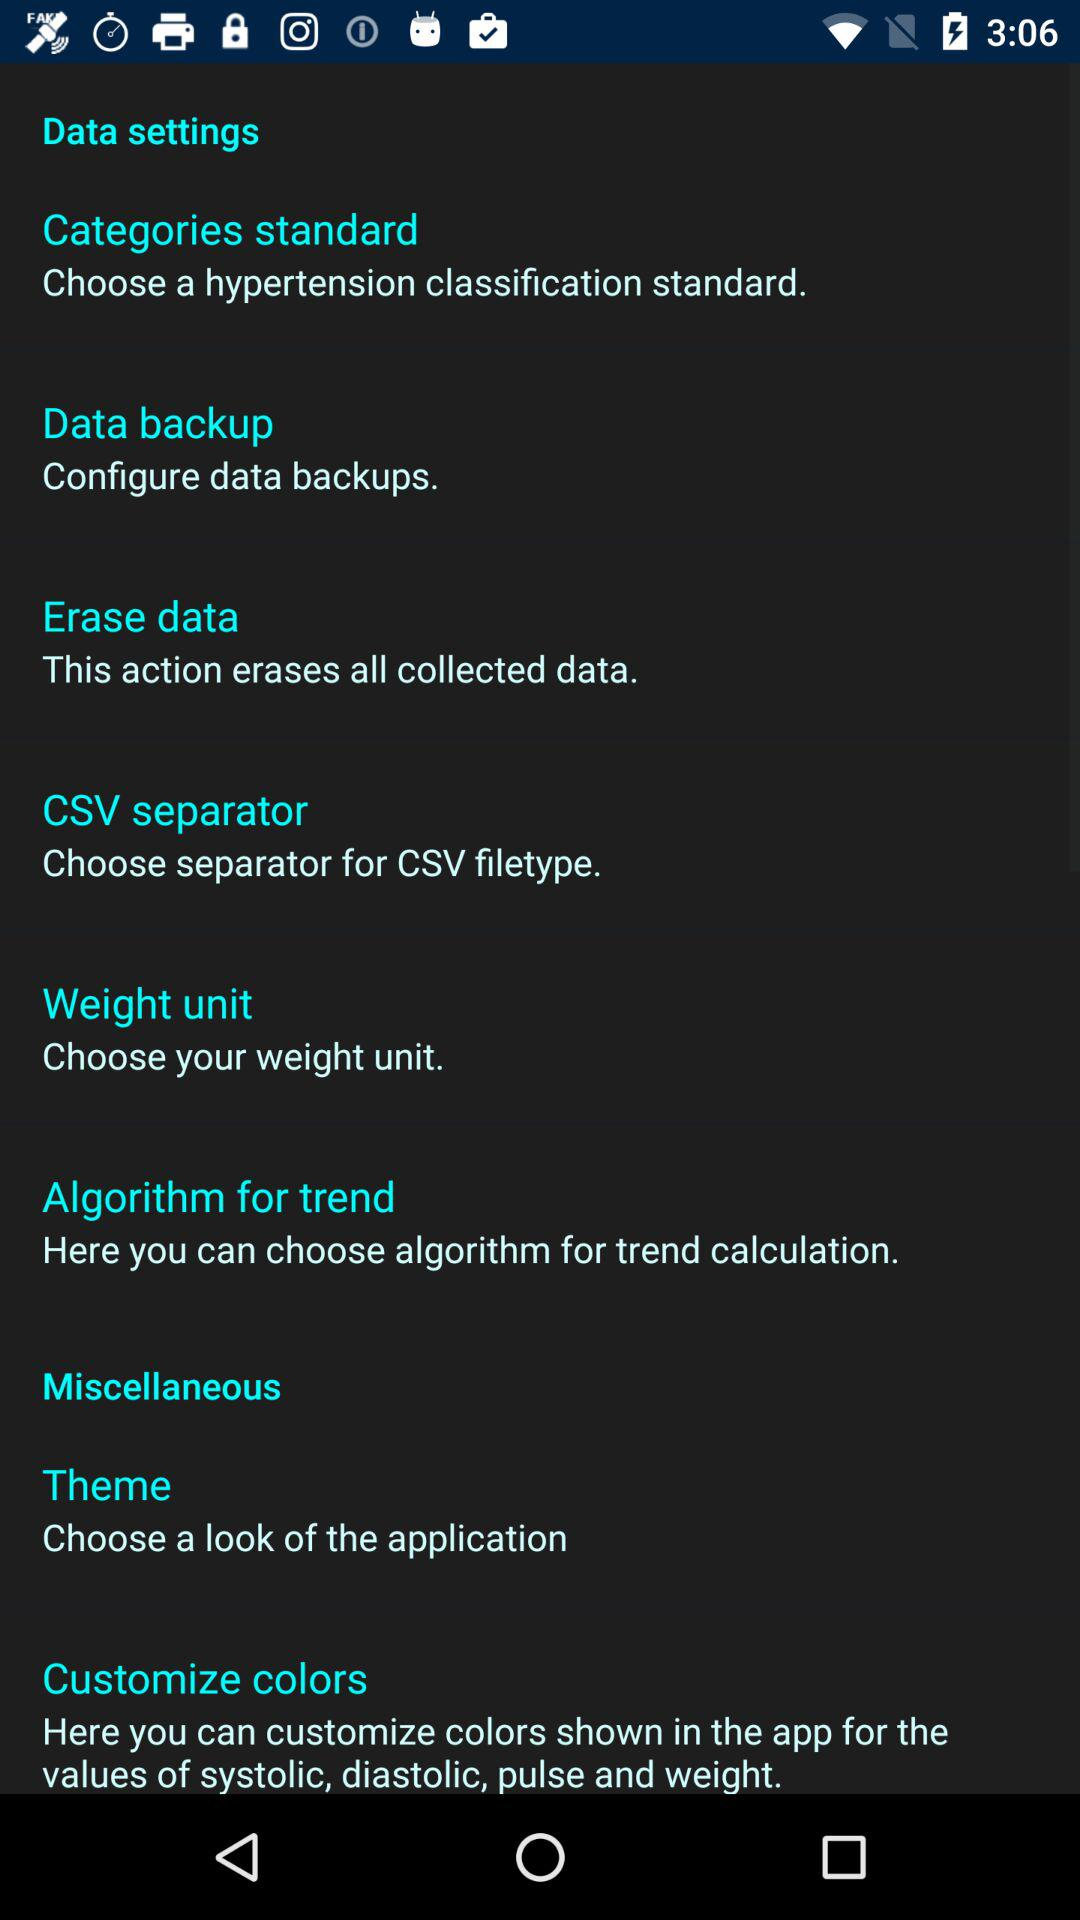How many items are in the 'Data settings' section?
Answer the question using a single word or phrase. 6 